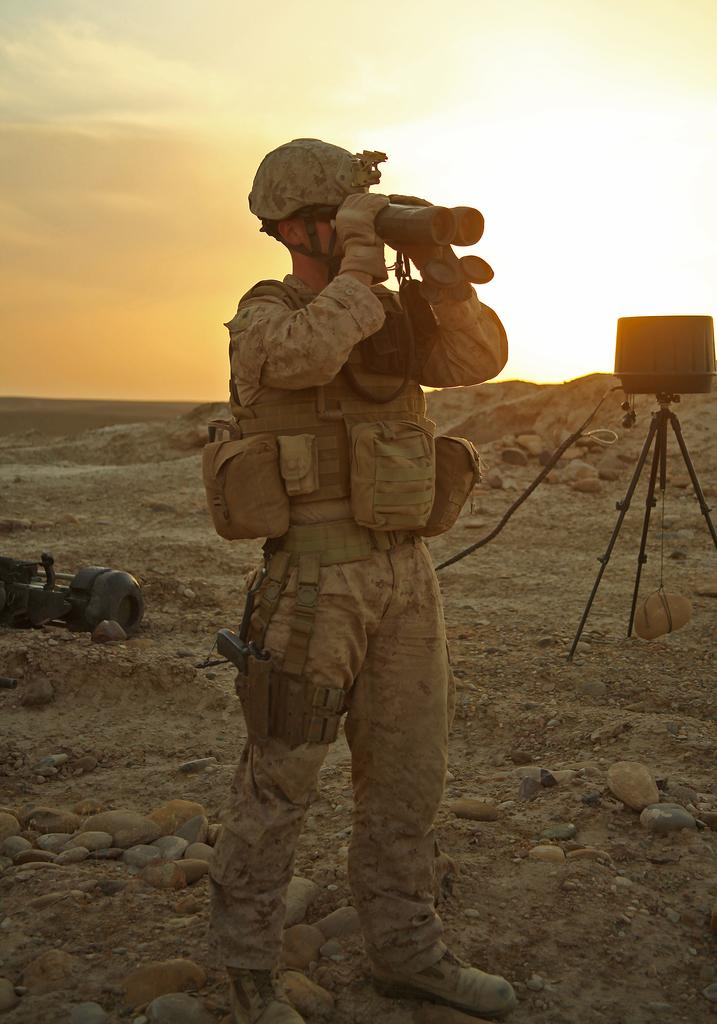What is the person in the image doing? The person is capturing something. What can be seen in the sky in the image? The sky is visible at the top of the image, and sunshine is present. What type of silk is being used to protect the person's throat in the image? There is no silk or mention of a throat in the image; the person is simply capturing something. 